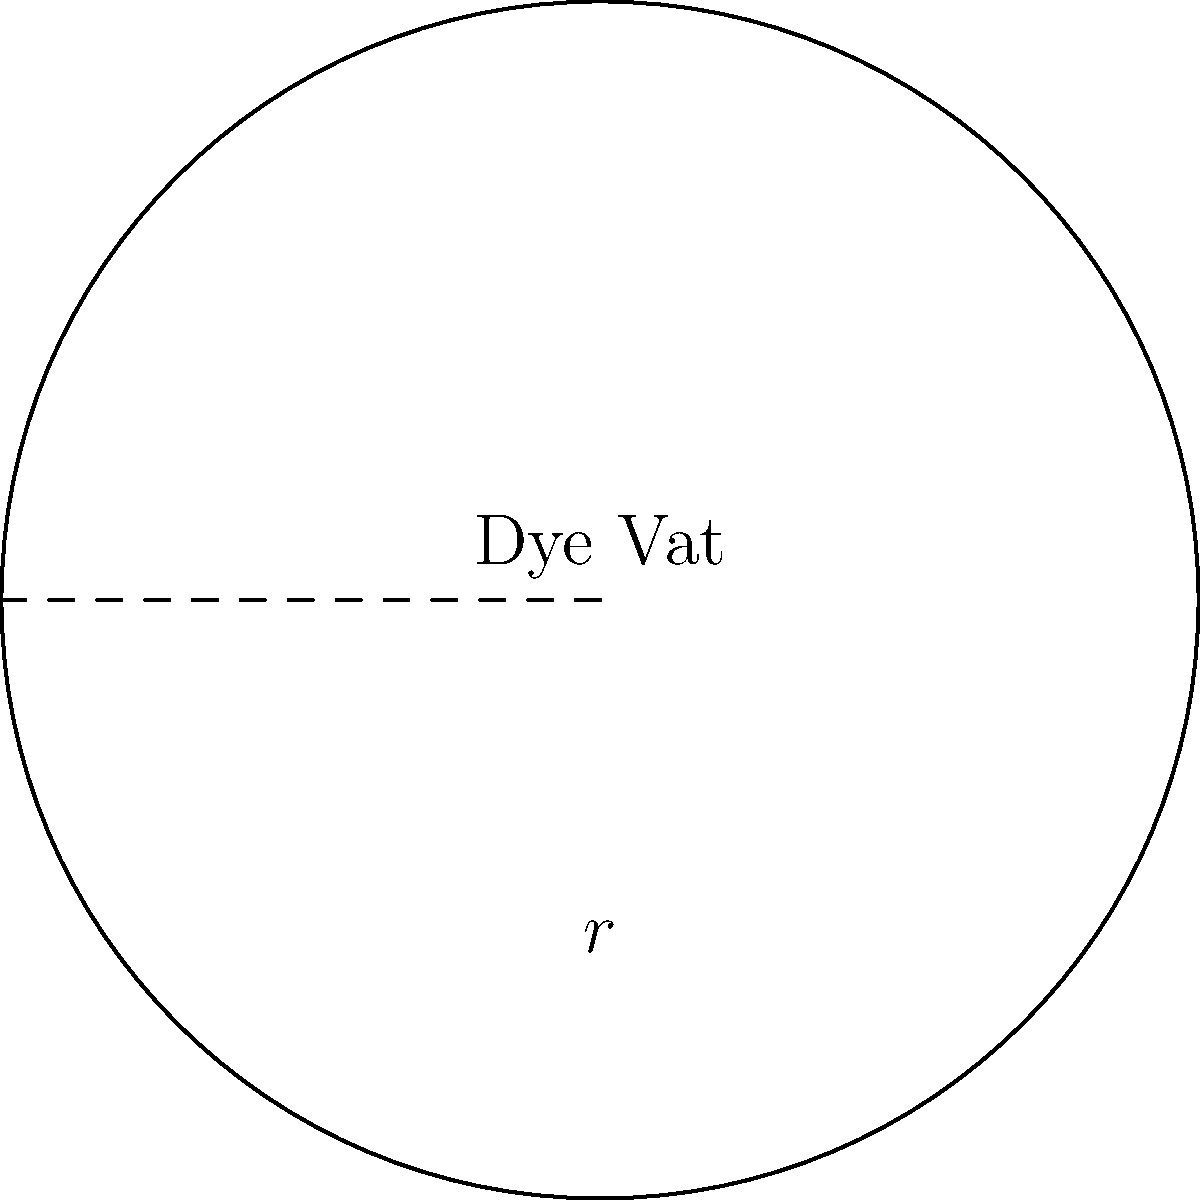A circular dye vat in our sustainable fashion factory has a radius of 3 meters. We want to install a water-saving barrier around its perimeter. If each meter of barrier reduces water usage by 5 liters per day, how many liters of water can we save daily by installing this barrier? To solve this problem, we need to follow these steps:

1. Calculate the perimeter of the circular dye vat:
   The formula for the perimeter (circumference) of a circle is $P = 2\pi r$, where $r$ is the radius.
   $P = 2 \times \pi \times 3 = 6\pi$ meters

2. Round the perimeter to the nearest whole number:
   $6\pi \approx 18.85$ meters, which rounds to 19 meters

3. Calculate the water savings:
   Each meter saves 5 liters per day.
   Total savings = Length of barrier × Savings per meter
   $19 \times 5 = 95$ liters per day

Therefore, by installing the water-saving barrier around the circular dye vat, we can save approximately 95 liters of water per day.
Answer: 95 liters 